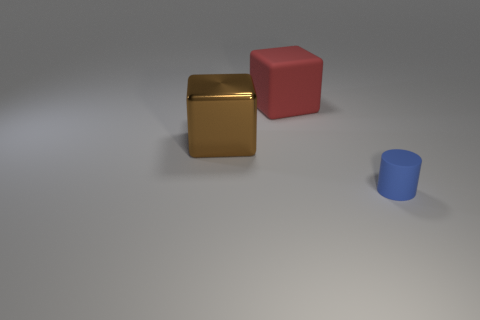Are there any cylinders that are behind the thing that is right of the matte object behind the tiny blue rubber object? no 